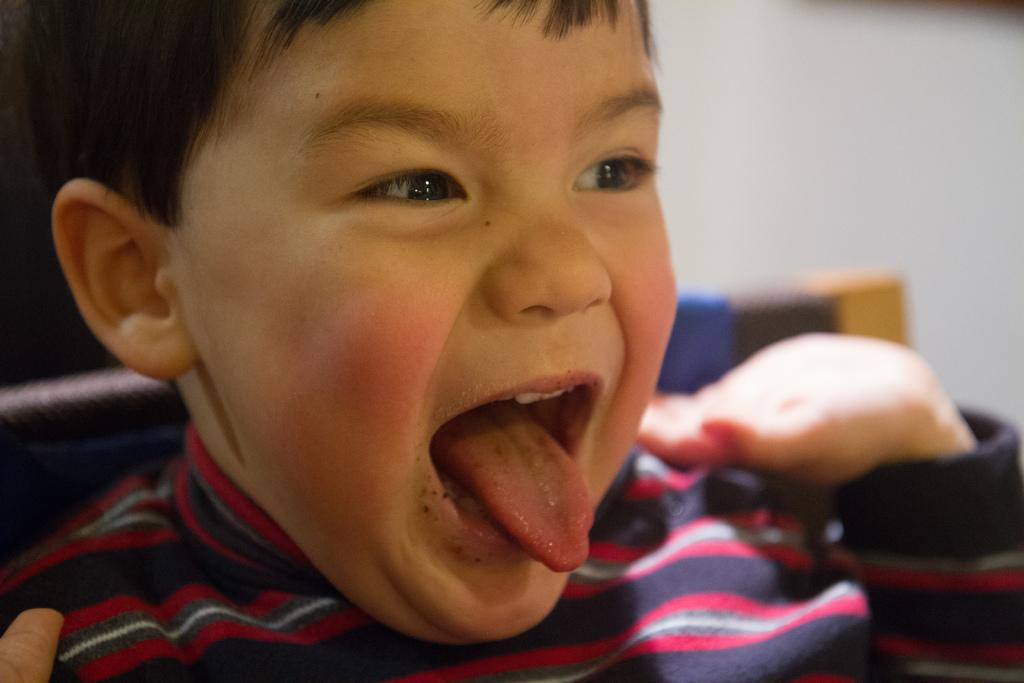Who is the main subject in the image? There is a boy in the image. What is the boy doing in the image? The boy is opening his mouth. What is the boy wearing in the image? The boy is wearing a shirt. What can be seen in the background of the image? There is a chair and a wall in the background of the image. What type of trouble is the deer causing in the image? There is no deer present in the image, so it is not possible to determine any trouble caused by a deer. 